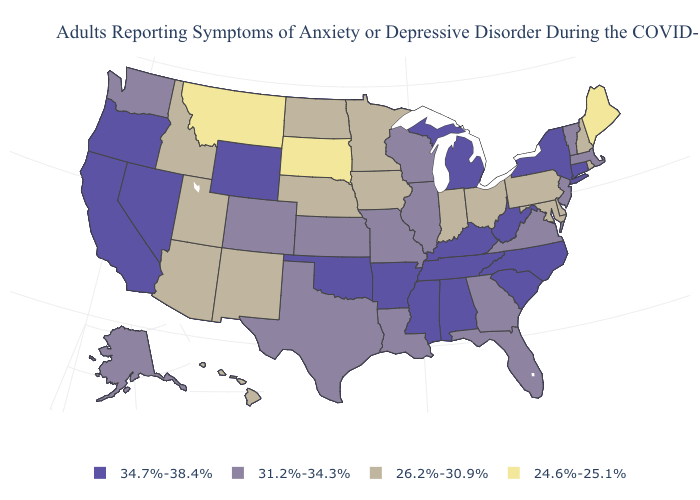What is the value of Ohio?
Be succinct. 26.2%-30.9%. Does the first symbol in the legend represent the smallest category?
Concise answer only. No. Name the states that have a value in the range 24.6%-25.1%?
Write a very short answer. Maine, Montana, South Dakota. What is the value of Alaska?
Write a very short answer. 31.2%-34.3%. Among the states that border Washington , which have the highest value?
Quick response, please. Oregon. Name the states that have a value in the range 26.2%-30.9%?
Be succinct. Arizona, Delaware, Hawaii, Idaho, Indiana, Iowa, Maryland, Minnesota, Nebraska, New Hampshire, New Mexico, North Dakota, Ohio, Pennsylvania, Rhode Island, Utah. What is the value of Maryland?
Quick response, please. 26.2%-30.9%. Among the states that border Kansas , does Oklahoma have the highest value?
Be succinct. Yes. Is the legend a continuous bar?
Short answer required. No. Name the states that have a value in the range 34.7%-38.4%?
Write a very short answer. Alabama, Arkansas, California, Connecticut, Kentucky, Michigan, Mississippi, Nevada, New York, North Carolina, Oklahoma, Oregon, South Carolina, Tennessee, West Virginia, Wyoming. What is the value of Indiana?
Concise answer only. 26.2%-30.9%. Which states have the highest value in the USA?
Short answer required. Alabama, Arkansas, California, Connecticut, Kentucky, Michigan, Mississippi, Nevada, New York, North Carolina, Oklahoma, Oregon, South Carolina, Tennessee, West Virginia, Wyoming. Name the states that have a value in the range 24.6%-25.1%?
Be succinct. Maine, Montana, South Dakota. Which states have the lowest value in the MidWest?
Write a very short answer. South Dakota. Name the states that have a value in the range 24.6%-25.1%?
Answer briefly. Maine, Montana, South Dakota. 